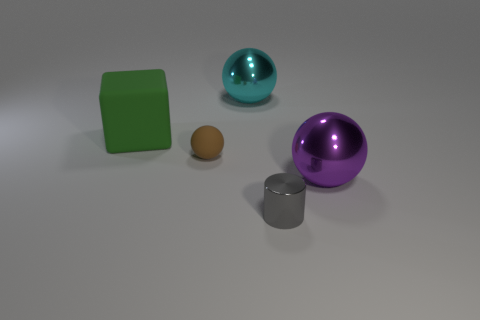Is the gray cylinder the same size as the brown rubber thing?
Your answer should be compact. Yes. Are there more blocks that are right of the big green rubber block than big cyan metallic things?
Make the answer very short. No. What size is the purple object that is the same material as the tiny cylinder?
Your response must be concise. Large. There is a cyan metallic ball; are there any brown objects to the right of it?
Give a very brief answer. No. Does the big cyan thing have the same shape as the small brown rubber object?
Your answer should be compact. Yes. There is a cyan sphere behind the big thing that is on the right side of the metallic object that is behind the brown ball; how big is it?
Keep it short and to the point. Large. What is the material of the large purple thing?
Make the answer very short. Metal. Is the shape of the small brown rubber thing the same as the shiny object that is on the right side of the gray shiny object?
Give a very brief answer. Yes. What material is the small object that is behind the big thing right of the object that is behind the green rubber object?
Give a very brief answer. Rubber. What number of metallic things are there?
Your response must be concise. 3. 